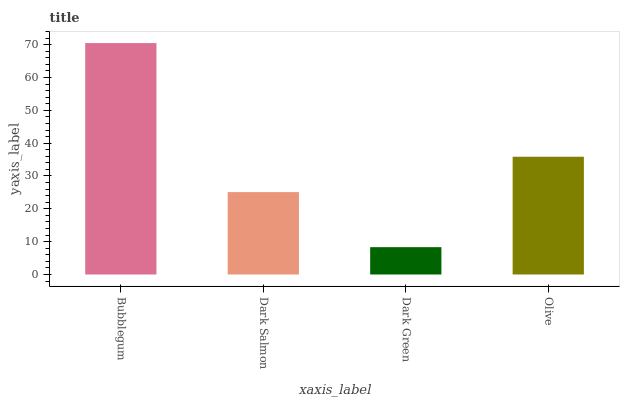Is Dark Green the minimum?
Answer yes or no. Yes. Is Bubblegum the maximum?
Answer yes or no. Yes. Is Dark Salmon the minimum?
Answer yes or no. No. Is Dark Salmon the maximum?
Answer yes or no. No. Is Bubblegum greater than Dark Salmon?
Answer yes or no. Yes. Is Dark Salmon less than Bubblegum?
Answer yes or no. Yes. Is Dark Salmon greater than Bubblegum?
Answer yes or no. No. Is Bubblegum less than Dark Salmon?
Answer yes or no. No. Is Olive the high median?
Answer yes or no. Yes. Is Dark Salmon the low median?
Answer yes or no. Yes. Is Bubblegum the high median?
Answer yes or no. No. Is Olive the low median?
Answer yes or no. No. 